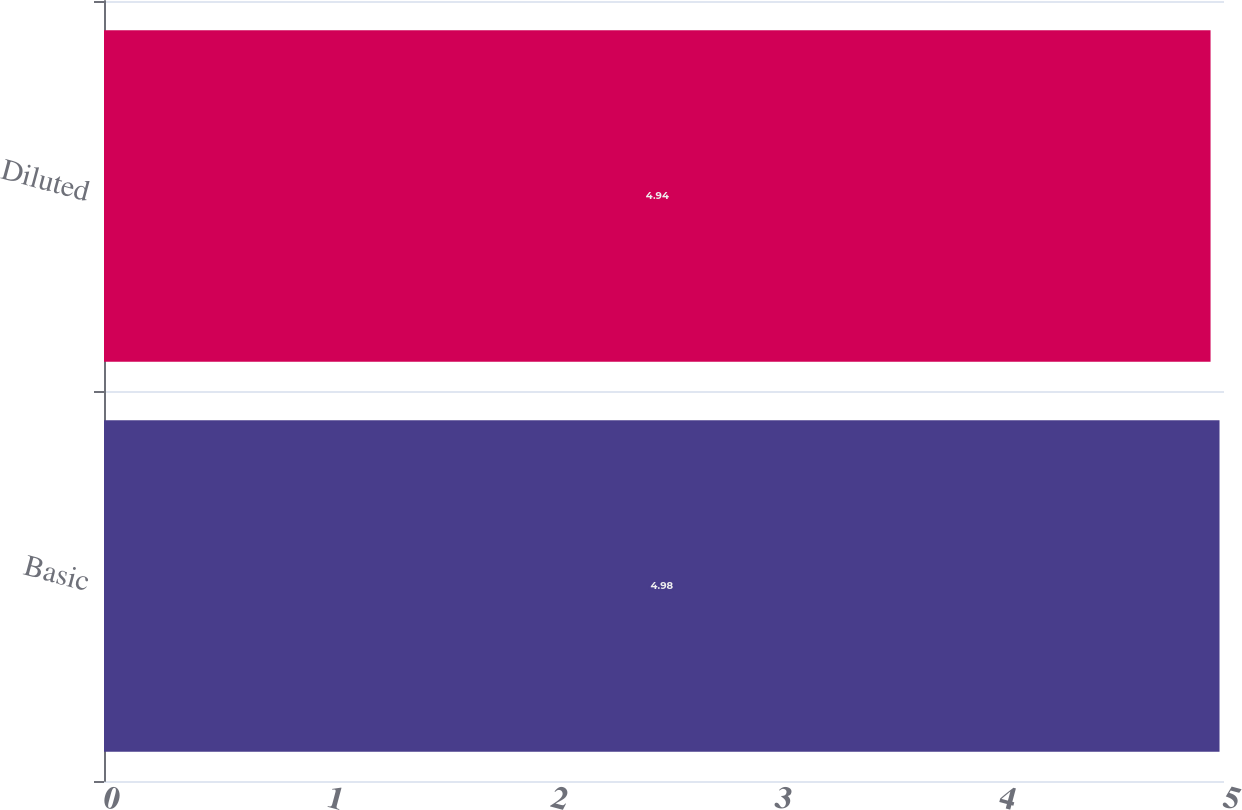Convert chart to OTSL. <chart><loc_0><loc_0><loc_500><loc_500><bar_chart><fcel>Basic<fcel>Diluted<nl><fcel>4.98<fcel>4.94<nl></chart> 